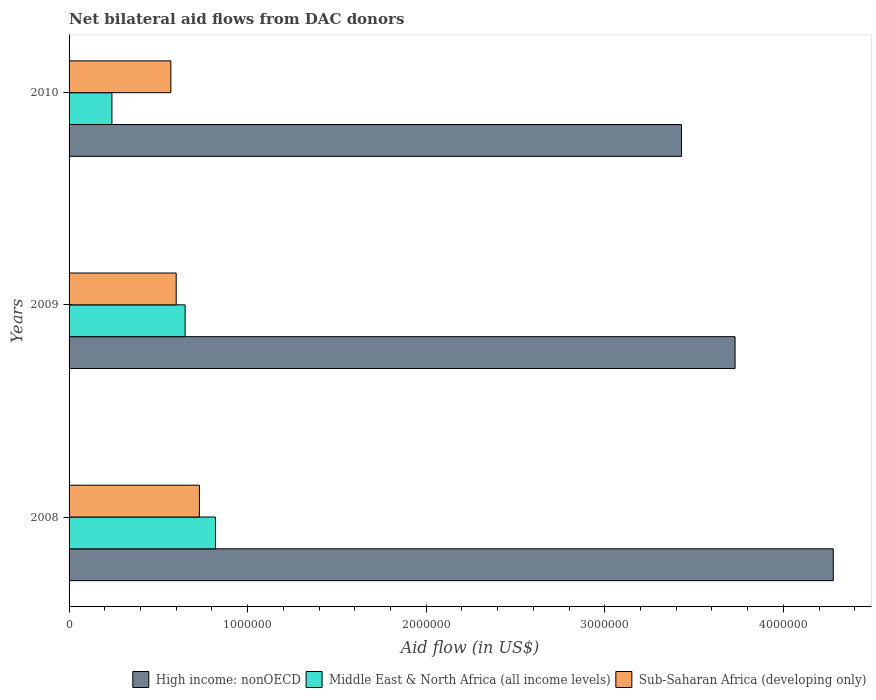How many different coloured bars are there?
Give a very brief answer. 3. Are the number of bars per tick equal to the number of legend labels?
Ensure brevity in your answer.  Yes. Are the number of bars on each tick of the Y-axis equal?
Provide a succinct answer. Yes. What is the net bilateral aid flow in High income: nonOECD in 2009?
Make the answer very short. 3.73e+06. Across all years, what is the maximum net bilateral aid flow in Middle East & North Africa (all income levels)?
Your response must be concise. 8.20e+05. Across all years, what is the minimum net bilateral aid flow in Sub-Saharan Africa (developing only)?
Keep it short and to the point. 5.70e+05. What is the total net bilateral aid flow in Middle East & North Africa (all income levels) in the graph?
Give a very brief answer. 1.71e+06. What is the difference between the net bilateral aid flow in Sub-Saharan Africa (developing only) in 2009 and that in 2010?
Provide a short and direct response. 3.00e+04. What is the difference between the net bilateral aid flow in High income: nonOECD in 2010 and the net bilateral aid flow in Sub-Saharan Africa (developing only) in 2009?
Provide a succinct answer. 2.83e+06. What is the average net bilateral aid flow in High income: nonOECD per year?
Your answer should be compact. 3.81e+06. In the year 2009, what is the difference between the net bilateral aid flow in Sub-Saharan Africa (developing only) and net bilateral aid flow in Middle East & North Africa (all income levels)?
Make the answer very short. -5.00e+04. In how many years, is the net bilateral aid flow in Sub-Saharan Africa (developing only) greater than 1600000 US$?
Provide a short and direct response. 0. What is the ratio of the net bilateral aid flow in Sub-Saharan Africa (developing only) in 2008 to that in 2009?
Ensure brevity in your answer.  1.22. Is the difference between the net bilateral aid flow in Sub-Saharan Africa (developing only) in 2008 and 2009 greater than the difference between the net bilateral aid flow in Middle East & North Africa (all income levels) in 2008 and 2009?
Make the answer very short. No. What is the difference between the highest and the lowest net bilateral aid flow in Middle East & North Africa (all income levels)?
Offer a very short reply. 5.80e+05. In how many years, is the net bilateral aid flow in Sub-Saharan Africa (developing only) greater than the average net bilateral aid flow in Sub-Saharan Africa (developing only) taken over all years?
Keep it short and to the point. 1. What does the 3rd bar from the top in 2008 represents?
Your answer should be compact. High income: nonOECD. What does the 2nd bar from the bottom in 2008 represents?
Provide a short and direct response. Middle East & North Africa (all income levels). Are all the bars in the graph horizontal?
Give a very brief answer. Yes. Does the graph contain any zero values?
Provide a short and direct response. No. How are the legend labels stacked?
Keep it short and to the point. Horizontal. What is the title of the graph?
Keep it short and to the point. Net bilateral aid flows from DAC donors. What is the label or title of the X-axis?
Keep it short and to the point. Aid flow (in US$). What is the Aid flow (in US$) of High income: nonOECD in 2008?
Ensure brevity in your answer.  4.28e+06. What is the Aid flow (in US$) of Middle East & North Africa (all income levels) in 2008?
Keep it short and to the point. 8.20e+05. What is the Aid flow (in US$) of Sub-Saharan Africa (developing only) in 2008?
Your answer should be very brief. 7.30e+05. What is the Aid flow (in US$) in High income: nonOECD in 2009?
Your answer should be compact. 3.73e+06. What is the Aid flow (in US$) in Middle East & North Africa (all income levels) in 2009?
Offer a terse response. 6.50e+05. What is the Aid flow (in US$) of Sub-Saharan Africa (developing only) in 2009?
Your answer should be very brief. 6.00e+05. What is the Aid flow (in US$) of High income: nonOECD in 2010?
Your response must be concise. 3.43e+06. What is the Aid flow (in US$) of Middle East & North Africa (all income levels) in 2010?
Give a very brief answer. 2.40e+05. What is the Aid flow (in US$) of Sub-Saharan Africa (developing only) in 2010?
Ensure brevity in your answer.  5.70e+05. Across all years, what is the maximum Aid flow (in US$) in High income: nonOECD?
Give a very brief answer. 4.28e+06. Across all years, what is the maximum Aid flow (in US$) in Middle East & North Africa (all income levels)?
Ensure brevity in your answer.  8.20e+05. Across all years, what is the maximum Aid flow (in US$) of Sub-Saharan Africa (developing only)?
Keep it short and to the point. 7.30e+05. Across all years, what is the minimum Aid flow (in US$) of High income: nonOECD?
Provide a succinct answer. 3.43e+06. Across all years, what is the minimum Aid flow (in US$) of Sub-Saharan Africa (developing only)?
Your answer should be compact. 5.70e+05. What is the total Aid flow (in US$) of High income: nonOECD in the graph?
Provide a succinct answer. 1.14e+07. What is the total Aid flow (in US$) of Middle East & North Africa (all income levels) in the graph?
Your response must be concise. 1.71e+06. What is the total Aid flow (in US$) in Sub-Saharan Africa (developing only) in the graph?
Make the answer very short. 1.90e+06. What is the difference between the Aid flow (in US$) in Middle East & North Africa (all income levels) in 2008 and that in 2009?
Provide a short and direct response. 1.70e+05. What is the difference between the Aid flow (in US$) in High income: nonOECD in 2008 and that in 2010?
Your answer should be very brief. 8.50e+05. What is the difference between the Aid flow (in US$) of Middle East & North Africa (all income levels) in 2008 and that in 2010?
Keep it short and to the point. 5.80e+05. What is the difference between the Aid flow (in US$) of Middle East & North Africa (all income levels) in 2009 and that in 2010?
Give a very brief answer. 4.10e+05. What is the difference between the Aid flow (in US$) in High income: nonOECD in 2008 and the Aid flow (in US$) in Middle East & North Africa (all income levels) in 2009?
Provide a short and direct response. 3.63e+06. What is the difference between the Aid flow (in US$) in High income: nonOECD in 2008 and the Aid flow (in US$) in Sub-Saharan Africa (developing only) in 2009?
Your response must be concise. 3.68e+06. What is the difference between the Aid flow (in US$) of Middle East & North Africa (all income levels) in 2008 and the Aid flow (in US$) of Sub-Saharan Africa (developing only) in 2009?
Keep it short and to the point. 2.20e+05. What is the difference between the Aid flow (in US$) in High income: nonOECD in 2008 and the Aid flow (in US$) in Middle East & North Africa (all income levels) in 2010?
Your answer should be very brief. 4.04e+06. What is the difference between the Aid flow (in US$) in High income: nonOECD in 2008 and the Aid flow (in US$) in Sub-Saharan Africa (developing only) in 2010?
Make the answer very short. 3.71e+06. What is the difference between the Aid flow (in US$) of Middle East & North Africa (all income levels) in 2008 and the Aid flow (in US$) of Sub-Saharan Africa (developing only) in 2010?
Keep it short and to the point. 2.50e+05. What is the difference between the Aid flow (in US$) of High income: nonOECD in 2009 and the Aid flow (in US$) of Middle East & North Africa (all income levels) in 2010?
Provide a short and direct response. 3.49e+06. What is the difference between the Aid flow (in US$) in High income: nonOECD in 2009 and the Aid flow (in US$) in Sub-Saharan Africa (developing only) in 2010?
Provide a short and direct response. 3.16e+06. What is the difference between the Aid flow (in US$) in Middle East & North Africa (all income levels) in 2009 and the Aid flow (in US$) in Sub-Saharan Africa (developing only) in 2010?
Provide a short and direct response. 8.00e+04. What is the average Aid flow (in US$) in High income: nonOECD per year?
Your response must be concise. 3.81e+06. What is the average Aid flow (in US$) of Middle East & North Africa (all income levels) per year?
Provide a short and direct response. 5.70e+05. What is the average Aid flow (in US$) of Sub-Saharan Africa (developing only) per year?
Offer a very short reply. 6.33e+05. In the year 2008, what is the difference between the Aid flow (in US$) of High income: nonOECD and Aid flow (in US$) of Middle East & North Africa (all income levels)?
Your answer should be compact. 3.46e+06. In the year 2008, what is the difference between the Aid flow (in US$) in High income: nonOECD and Aid flow (in US$) in Sub-Saharan Africa (developing only)?
Your answer should be compact. 3.55e+06. In the year 2009, what is the difference between the Aid flow (in US$) in High income: nonOECD and Aid flow (in US$) in Middle East & North Africa (all income levels)?
Ensure brevity in your answer.  3.08e+06. In the year 2009, what is the difference between the Aid flow (in US$) of High income: nonOECD and Aid flow (in US$) of Sub-Saharan Africa (developing only)?
Give a very brief answer. 3.13e+06. In the year 2009, what is the difference between the Aid flow (in US$) in Middle East & North Africa (all income levels) and Aid flow (in US$) in Sub-Saharan Africa (developing only)?
Provide a succinct answer. 5.00e+04. In the year 2010, what is the difference between the Aid flow (in US$) of High income: nonOECD and Aid flow (in US$) of Middle East & North Africa (all income levels)?
Offer a terse response. 3.19e+06. In the year 2010, what is the difference between the Aid flow (in US$) of High income: nonOECD and Aid flow (in US$) of Sub-Saharan Africa (developing only)?
Your answer should be very brief. 2.86e+06. In the year 2010, what is the difference between the Aid flow (in US$) of Middle East & North Africa (all income levels) and Aid flow (in US$) of Sub-Saharan Africa (developing only)?
Your answer should be very brief. -3.30e+05. What is the ratio of the Aid flow (in US$) in High income: nonOECD in 2008 to that in 2009?
Make the answer very short. 1.15. What is the ratio of the Aid flow (in US$) of Middle East & North Africa (all income levels) in 2008 to that in 2009?
Offer a terse response. 1.26. What is the ratio of the Aid flow (in US$) in Sub-Saharan Africa (developing only) in 2008 to that in 2009?
Make the answer very short. 1.22. What is the ratio of the Aid flow (in US$) in High income: nonOECD in 2008 to that in 2010?
Provide a succinct answer. 1.25. What is the ratio of the Aid flow (in US$) of Middle East & North Africa (all income levels) in 2008 to that in 2010?
Your answer should be compact. 3.42. What is the ratio of the Aid flow (in US$) of Sub-Saharan Africa (developing only) in 2008 to that in 2010?
Give a very brief answer. 1.28. What is the ratio of the Aid flow (in US$) in High income: nonOECD in 2009 to that in 2010?
Your answer should be compact. 1.09. What is the ratio of the Aid flow (in US$) in Middle East & North Africa (all income levels) in 2009 to that in 2010?
Keep it short and to the point. 2.71. What is the ratio of the Aid flow (in US$) of Sub-Saharan Africa (developing only) in 2009 to that in 2010?
Your answer should be compact. 1.05. What is the difference between the highest and the lowest Aid flow (in US$) of High income: nonOECD?
Provide a short and direct response. 8.50e+05. What is the difference between the highest and the lowest Aid flow (in US$) in Middle East & North Africa (all income levels)?
Ensure brevity in your answer.  5.80e+05. 